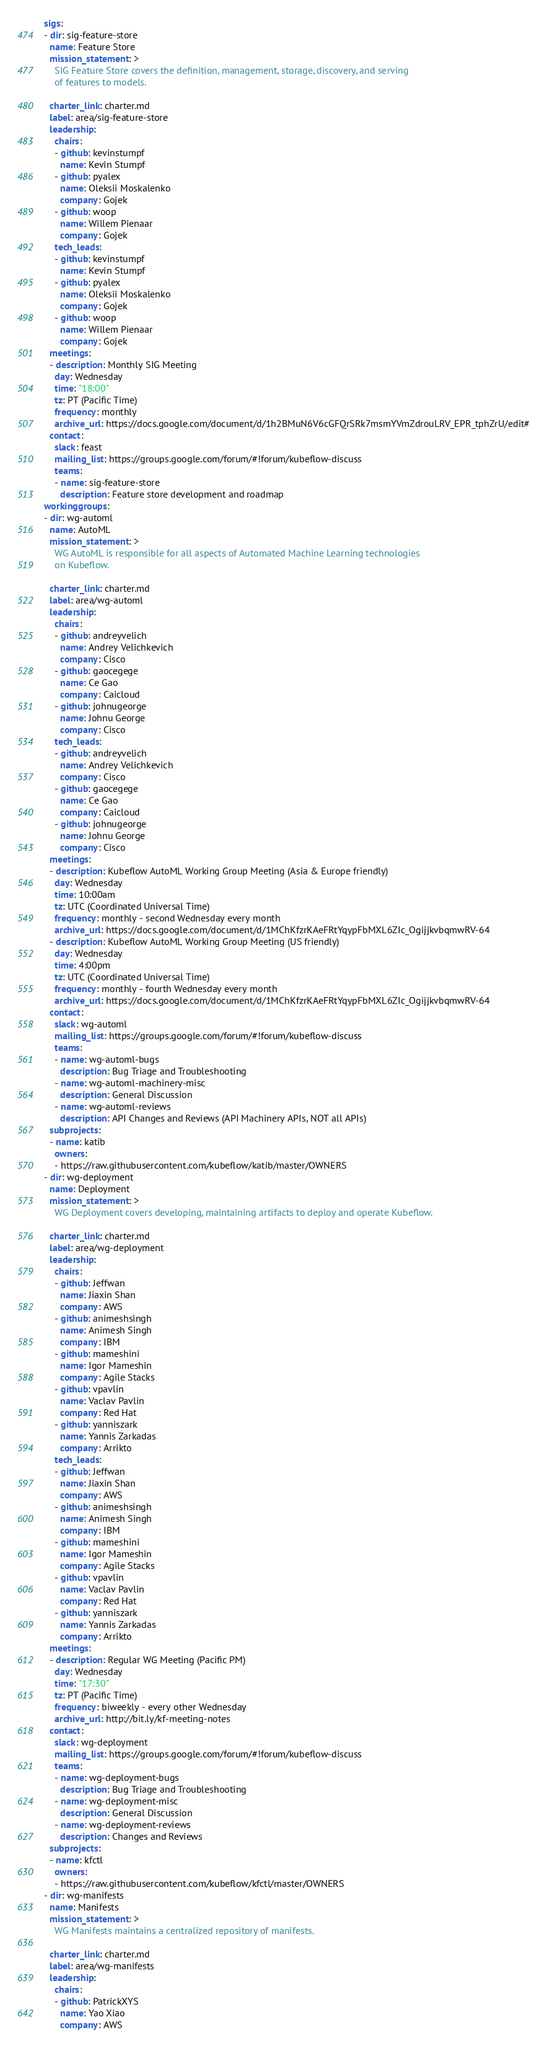<code> <loc_0><loc_0><loc_500><loc_500><_YAML_>sigs:
- dir: sig-feature-store
  name: Feature Store
  mission_statement: >
    SIG Feature Store covers the definition, management, storage, discovery, and serving
    of features to models.

  charter_link: charter.md
  label: area/sig-feature-store
  leadership:
    chairs:
    - github: kevinstumpf
      name: Kevin Stumpf
    - github: pyalex
      name: Oleksii Moskalenko
      company: Gojek
    - github: woop
      name: Willem Pienaar
      company: Gojek
    tech_leads:
    - github: kevinstumpf
      name: Kevin Stumpf
    - github: pyalex
      name: Oleksii Moskalenko
      company: Gojek
    - github: woop
      name: Willem Pienaar
      company: Gojek
  meetings:
  - description: Monthly SIG Meeting
    day: Wednesday
    time: "18:00"
    tz: PT (Pacific Time)
    frequency: monthly
    archive_url: https://docs.google.com/document/d/1h2BMuN6V6cGFQrSRk7msmYVmZdrouLRV_EPR_tphZrU/edit#
  contact:
    slack: feast
    mailing_list: https://groups.google.com/forum/#!forum/kubeflow-discuss
    teams:
    - name: sig-feature-store
      description: Feature store development and roadmap
workinggroups:
- dir: wg-automl
  name: AutoML
  mission_statement: >
    WG AutoML is responsible for all aspects of Automated Machine Learning technologies
    on Kubeflow.

  charter_link: charter.md
  label: area/wg-automl
  leadership:
    chairs:
    - github: andreyvelich
      name: Andrey Velichkevich
      company: Cisco
    - github: gaocegege
      name: Ce Gao
      company: Caicloud
    - github: johnugeorge
      name: Johnu George
      company: Cisco
    tech_leads:
    - github: andreyvelich
      name: Andrey Velichkevich
      company: Cisco
    - github: gaocegege
      name: Ce Gao
      company: Caicloud
    - github: johnugeorge
      name: Johnu George
      company: Cisco
  meetings:
  - description: Kubeflow AutoML Working Group Meeting (Asia & Europe friendly)
    day: Wednesday
    time: 10:00am
    tz: UTC (Coordinated Universal Time)
    frequency: monthly - second Wednesday every month
    archive_url: https://docs.google.com/document/d/1MChKfzrKAeFRtYqypFbMXL6ZIc_OgijjkvbqmwRV-64
  - description: Kubeflow AutoML Working Group Meeting (US friendly)
    day: Wednesday
    time: 4:00pm
    tz: UTC (Coordinated Universal Time)
    frequency: monthly - fourth Wednesday every month
    archive_url: https://docs.google.com/document/d/1MChKfzrKAeFRtYqypFbMXL6ZIc_OgijjkvbqmwRV-64
  contact:
    slack: wg-automl
    mailing_list: https://groups.google.com/forum/#!forum/kubeflow-discuss
    teams:
    - name: wg-automl-bugs
      description: Bug Triage and Troubleshooting
    - name: wg-automl-machinery-misc
      description: General Discussion
    - name: wg-automl-reviews
      description: API Changes and Reviews (API Machinery APIs, NOT all APIs)
  subprojects:
  - name: katib
    owners:
    - https://raw.githubusercontent.com/kubeflow/katib/master/OWNERS
- dir: wg-deployment
  name: Deployment
  mission_statement: >
    WG Deployment covers developing, maintaining artifacts to deploy and operate Kubeflow.

  charter_link: charter.md
  label: area/wg-deployment
  leadership:
    chairs:
    - github: Jeffwan
      name: Jiaxin Shan
      company: AWS
    - github: animeshsingh
      name: Animesh Singh
      company: IBM
    - github: mameshini
      name: Igor Mameshin
      company: Agile Stacks
    - github: vpavlin
      name: Vaclav Pavlin
      company: Red Hat
    - github: yanniszark
      name: Yannis Zarkadas
      company: Arrikto
    tech_leads:
    - github: Jeffwan
      name: Jiaxin Shan
      company: AWS
    - github: animeshsingh
      name: Animesh Singh
      company: IBM
    - github: mameshini
      name: Igor Mameshin
      company: Agile Stacks
    - github: vpavlin
      name: Vaclav Pavlin
      company: Red Hat
    - github: yanniszark
      name: Yannis Zarkadas
      company: Arrikto
  meetings:
  - description: Regular WG Meeting (Pacific PM)
    day: Wednesday
    time: "17:30"
    tz: PT (Pacific Time)
    frequency: biweekly - every other Wednesday
    archive_url: http://bit.ly/kf-meeting-notes
  contact:
    slack: wg-deployment
    mailing_list: https://groups.google.com/forum/#!forum/kubeflow-discuss
    teams:
    - name: wg-deployment-bugs
      description: Bug Triage and Troubleshooting
    - name: wg-deployment-misc
      description: General Discussion
    - name: wg-deployment-reviews
      description: Changes and Reviews
  subprojects:
  - name: kfctl
    owners:
    - https://raw.githubusercontent.com/kubeflow/kfctl/master/OWNERS
- dir: wg-manifests
  name: Manifests
  mission_statement: >
    WG Manifests maintains a centralized repository of manifests.

  charter_link: charter.md
  label: area/wg-manifests
  leadership:
    chairs:
    - github: PatrickXYS
      name: Yao Xiao
      company: AWS</code> 